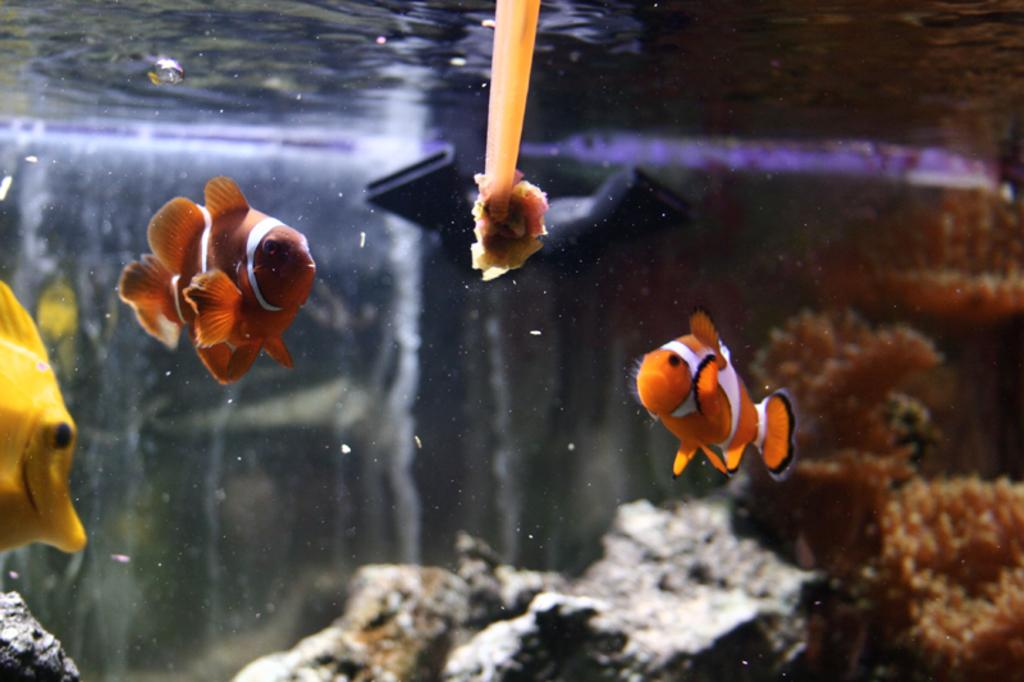What type of animals can be seen in the water in the image? There are fishes present in the water in the image. What other living organisms can be seen in the water in the image? There are marine plants present in the water in the image. What type of sweater is the fish wearing in the image? There is no sweater present in the image, as fishes do not wear clothing. Can you tell me who approved the presence of the marine plants in the image? There is no approval process mentioned or implied in the image, as it is a static representation of the underwater environment. 